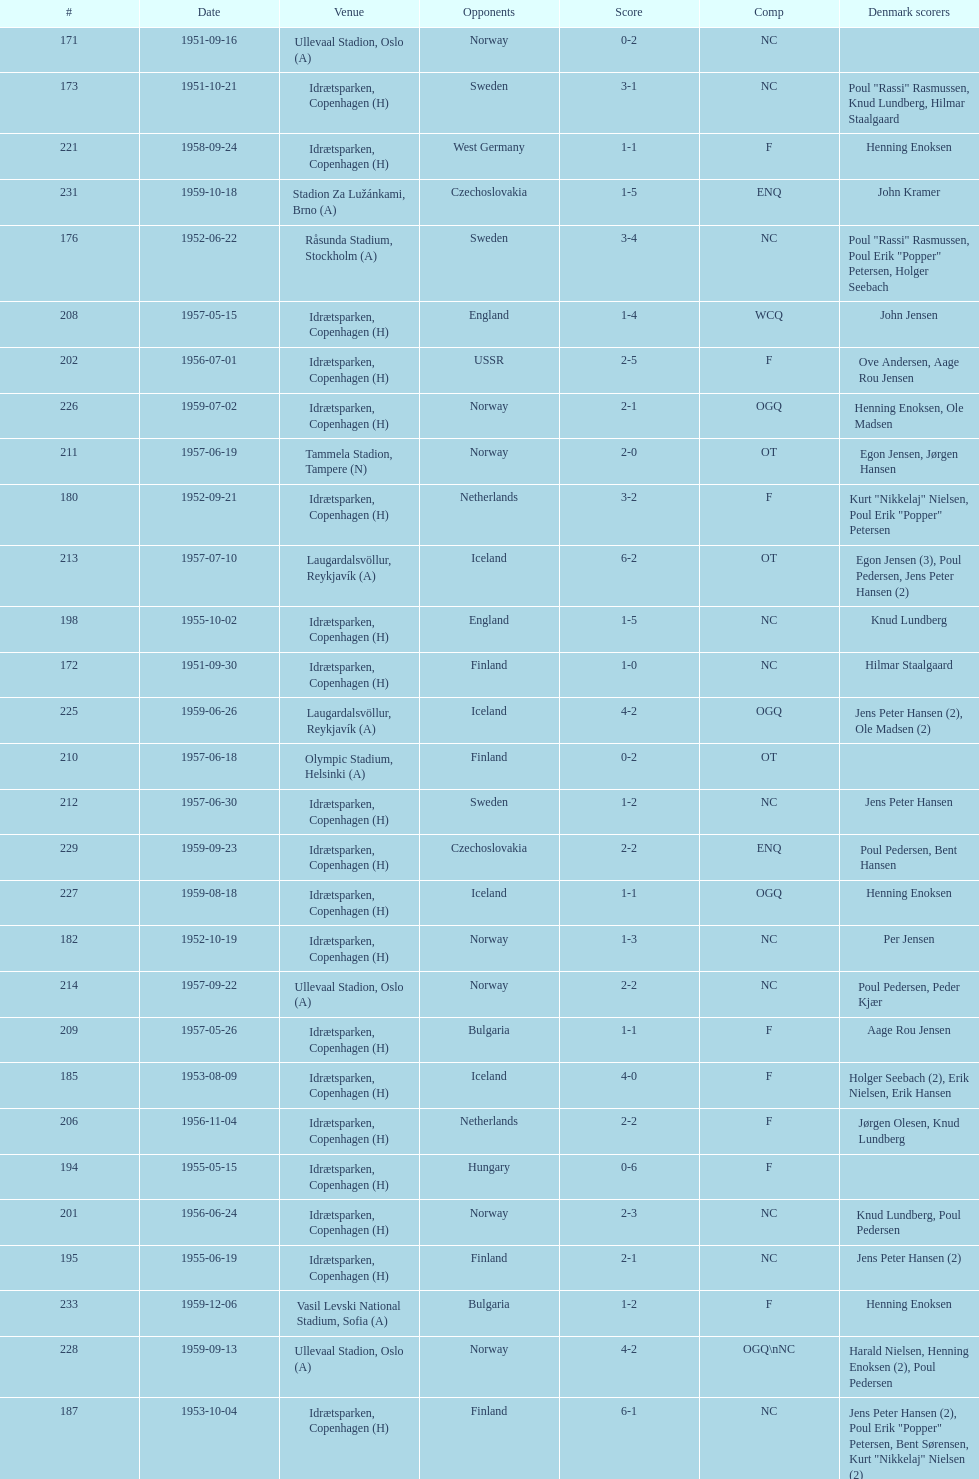What is the name of the venue listed before olympic stadium on 1950-08-27? Aarhus Stadion, Aarhus. 